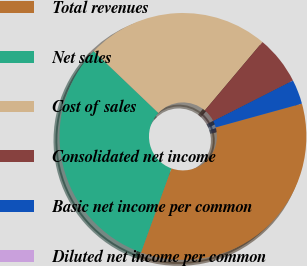Convert chart. <chart><loc_0><loc_0><loc_500><loc_500><pie_chart><fcel>Total revenues<fcel>Net sales<fcel>Cost of sales<fcel>Consolidated net income<fcel>Basic net income per common<fcel>Diluted net income per common<nl><fcel>34.81%<fcel>31.62%<fcel>24.01%<fcel>6.38%<fcel>3.19%<fcel>0.0%<nl></chart> 